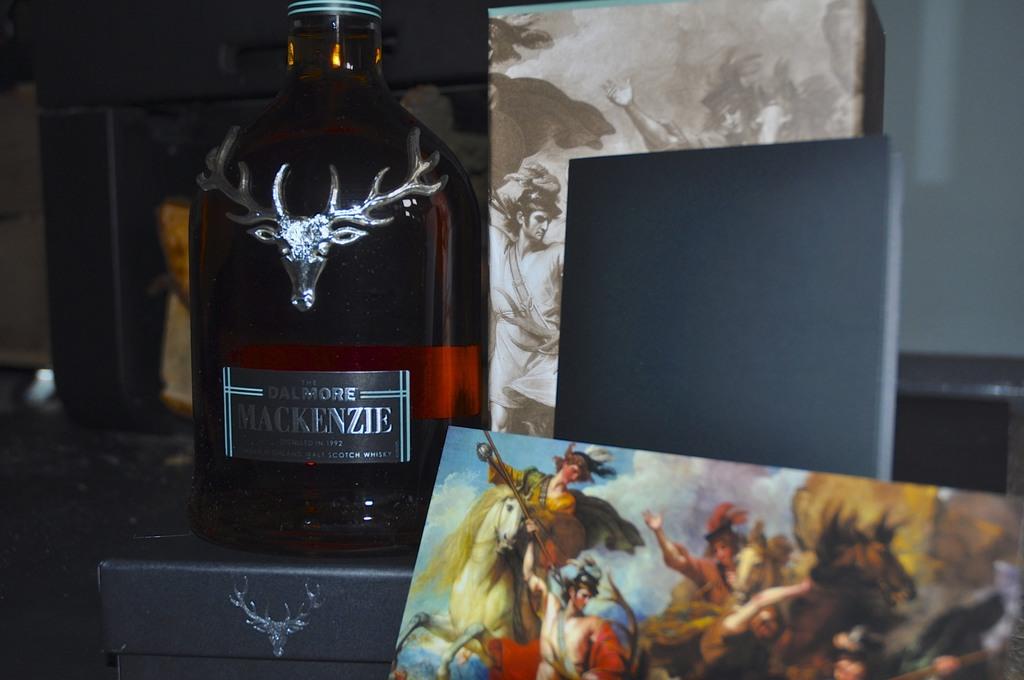What brand of beverage is in the bottle?
Your answer should be very brief. Mackenzie. 